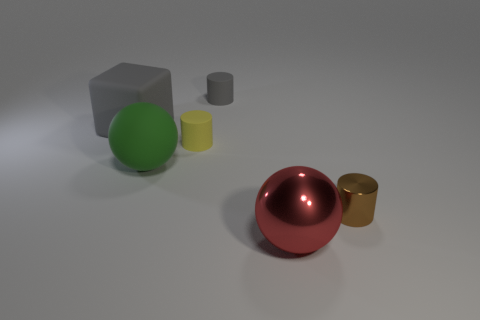There is a small metallic object that is behind the large red thing; what is its color?
Provide a short and direct response. Brown. Is the number of big red balls that are behind the yellow matte thing the same as the number of green metal blocks?
Make the answer very short. Yes. There is a matte thing that is both left of the yellow cylinder and behind the large rubber sphere; what is its shape?
Offer a terse response. Cube. There is another thing that is the same shape as the green object; what is its color?
Your answer should be compact. Red. Are there any other things that are the same color as the rubber block?
Offer a very short reply. Yes. The shiny thing behind the metal object that is on the left side of the metal object that is right of the red object is what shape?
Your answer should be very brief. Cylinder. There is a gray object behind the gray block; does it have the same size as the object that is in front of the shiny cylinder?
Offer a terse response. No. What number of other things have the same material as the small brown thing?
Give a very brief answer. 1. There is a gray cylinder that is on the right side of the large gray block that is on the left side of the yellow rubber object; what number of tiny gray things are behind it?
Provide a short and direct response. 0. Is the shape of the large green matte object the same as the tiny metallic thing?
Your response must be concise. No. 